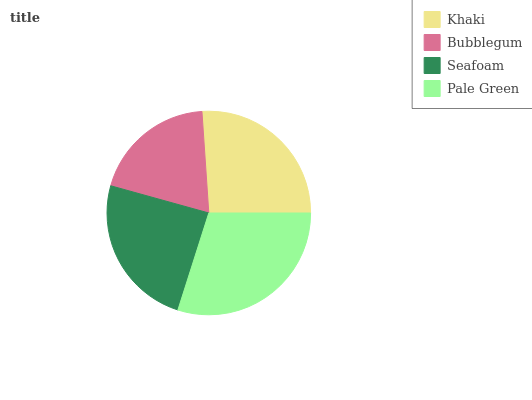Is Bubblegum the minimum?
Answer yes or no. Yes. Is Pale Green the maximum?
Answer yes or no. Yes. Is Seafoam the minimum?
Answer yes or no. No. Is Seafoam the maximum?
Answer yes or no. No. Is Seafoam greater than Bubblegum?
Answer yes or no. Yes. Is Bubblegum less than Seafoam?
Answer yes or no. Yes. Is Bubblegum greater than Seafoam?
Answer yes or no. No. Is Seafoam less than Bubblegum?
Answer yes or no. No. Is Khaki the high median?
Answer yes or no. Yes. Is Seafoam the low median?
Answer yes or no. Yes. Is Seafoam the high median?
Answer yes or no. No. Is Pale Green the low median?
Answer yes or no. No. 